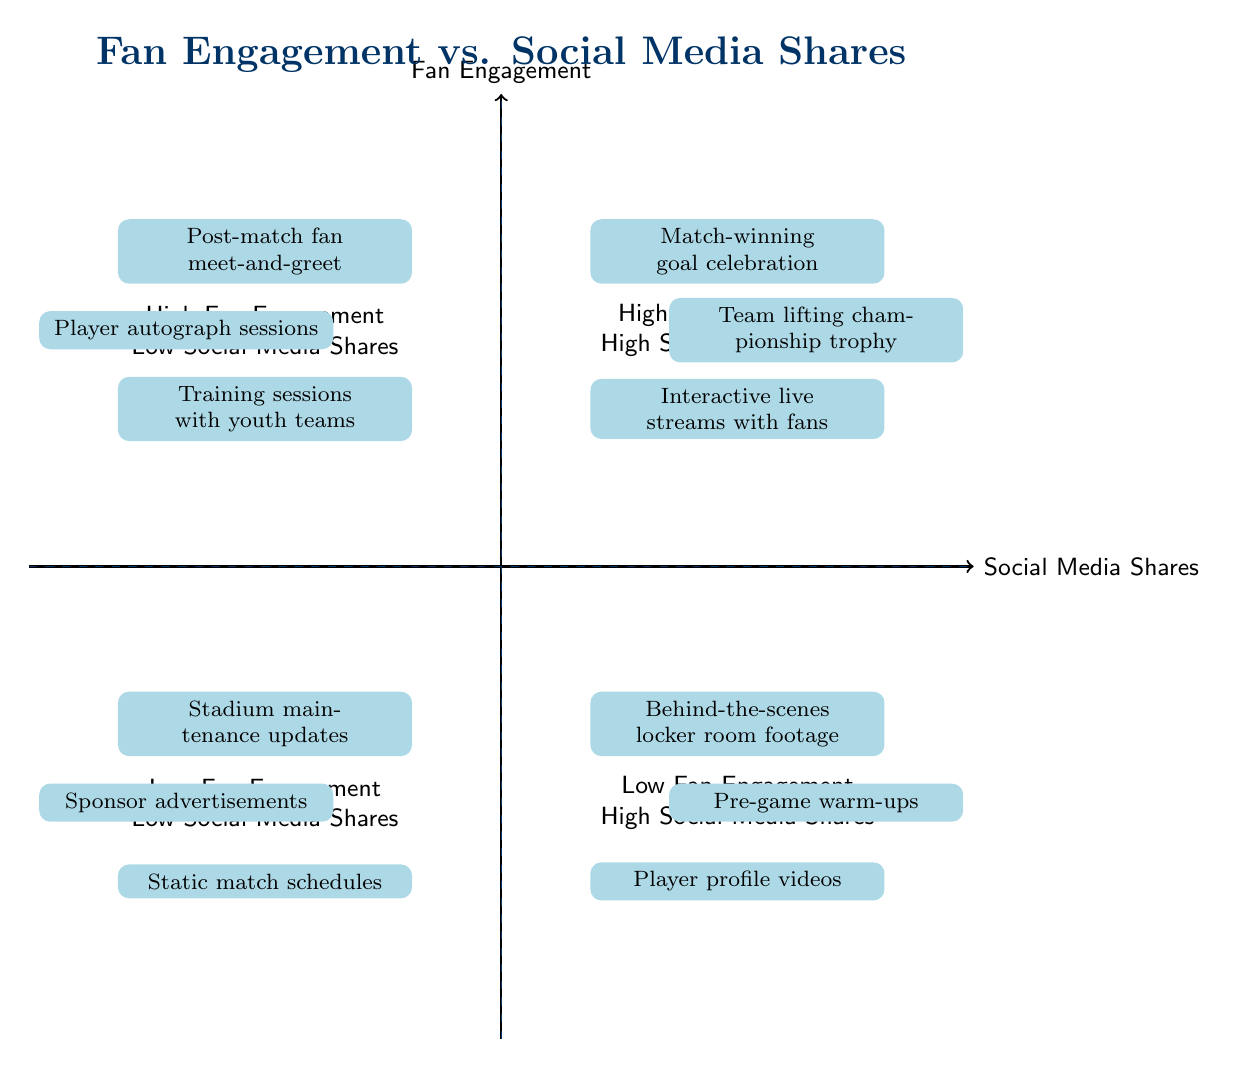What type of content is found in the High Fan Engagement - High Social Media Shares quadrant? The High Fan Engagement - High Social Media Shares quadrant contains three specific content types: Match-winning goal celebration, Team lifting championship trophy, and Interactive live streams with fans. These are all labeled in that quadrant of the diagram.
Answer: Match-winning goal celebration, Team lifting championship trophy, Interactive live streams with fans How many items are listed in the Low Fan Engagement - Low Social Media Shares quadrant? The Low Fan Engagement - Low Social Media Shares quadrant includes three items: Stadium maintenance updates, Sponsor advertisements, and Static match schedules. Counting these items gives a total of three.
Answer: 3 What is one example of content with Low Fan Engagement but High Social Media Shares? The data for the Low Fan Engagement - High Social Media Shares quadrant includes examples such as Behind-the-scenes locker room footage, Pre-game warm-ups, and Player profile videos. Selecting any of these is correct.
Answer: Behind-the-scenes locker room footage Which quadrant has content related to interactive live streams? The interactive live streams with fans is listed in the High Fan Engagement - High Social Media Shares quadrant, indicating that it fits criteria of both high engagement and high shares.
Answer: High Fan Engagement - High Social Media Shares Which type of content has the lowest reach and engagement according to the diagram? The content found in the Low Fan Engagement - Low Social Media Shares quadrant represents the lowest engagement and share metrics. Included in this category are items that likely do not generate much fan interaction or sharing on social media.
Answer: Low Fan Engagement - Low Social Media Shares 